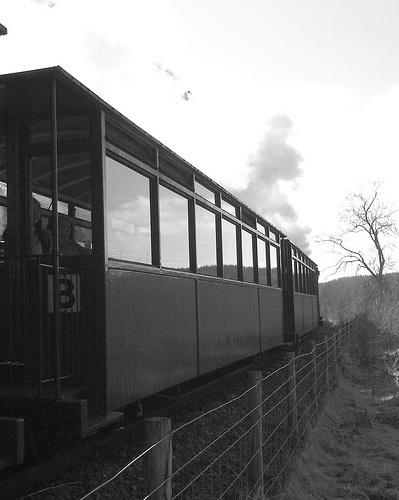Are there both cars and windows in the photograph? Yes, there are multiple cars and visible windows in the train compartments. 